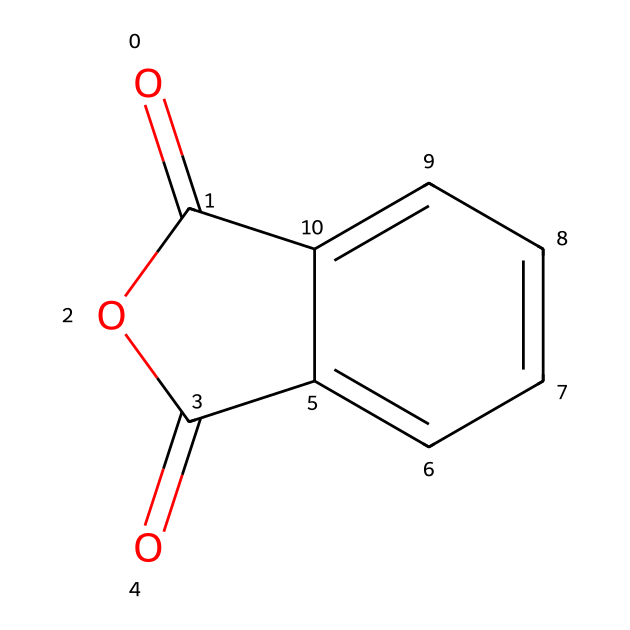What is the molecular formula of phthalic anhydride? To determine the molecular formula, we count the number of each type of atom present in the structure. In the provided SMILES, we see one carbonyl group indicating two carbon atoms (from -C=O) and additional five carbon atoms from the benzene ring. Thus, the total is eight carbons (C8), four hydrogens (H4), and three oxygens (O3). This gives the formula C8H4O3.
Answer: C8H4O3 How many carbon atoms are in the phthalic anhydride structure? By analyzing the structure from the SMILES, the main structure shows one ring with five carbons, and there are an additional two carbons from the carbonyl groups. Hence, the total number of carbon atoms is seven.
Answer: seven What type of functional groups are present in phthalic anhydride? The structure contains an anhydride functional group (-C(=O)O-C(=O)-) and a benzene ring demonstrating aromatic properties. Therefore, the functional groups here are anhydride and aromatic.
Answer: anhydride and aromatic How many oxygen atoms are present in the phthalic anhydride structure? The provided SMILES includes two carbonyl oxygen atoms related to the anhydride functionality and an additional aromatic oxygen likely from the stabilizing structure of the anhydride. Thus, the total number of oxygen atoms is three.
Answer: three What is the hybridization of the carbon atoms in the benzene ring of phthalic anhydride? The carbons in the benzene ring exhibit sp2 hybridization due to their involvement in double bonds and the planar structure typical of aromatic compounds, where each carbon is connected to another carbon and one hydrogen atom.
Answer: sp2 Is phthalic anhydride soluble in water? Phthalic anhydride has limited solubility in water due to its nonpolar benzene ring components despite having polar carbonyl groups; thus, it is slightly soluble in water but mainly dissolved in organic solvents.
Answer: slightly soluble 